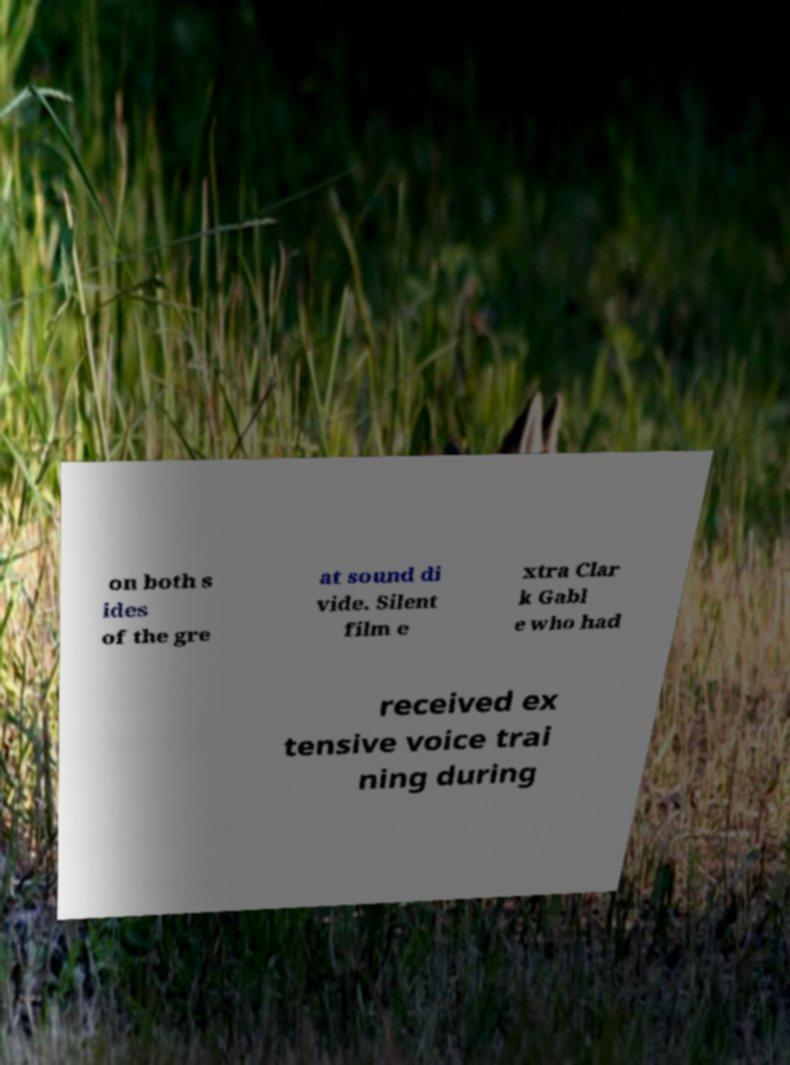Please identify and transcribe the text found in this image. on both s ides of the gre at sound di vide. Silent film e xtra Clar k Gabl e who had received ex tensive voice trai ning during 